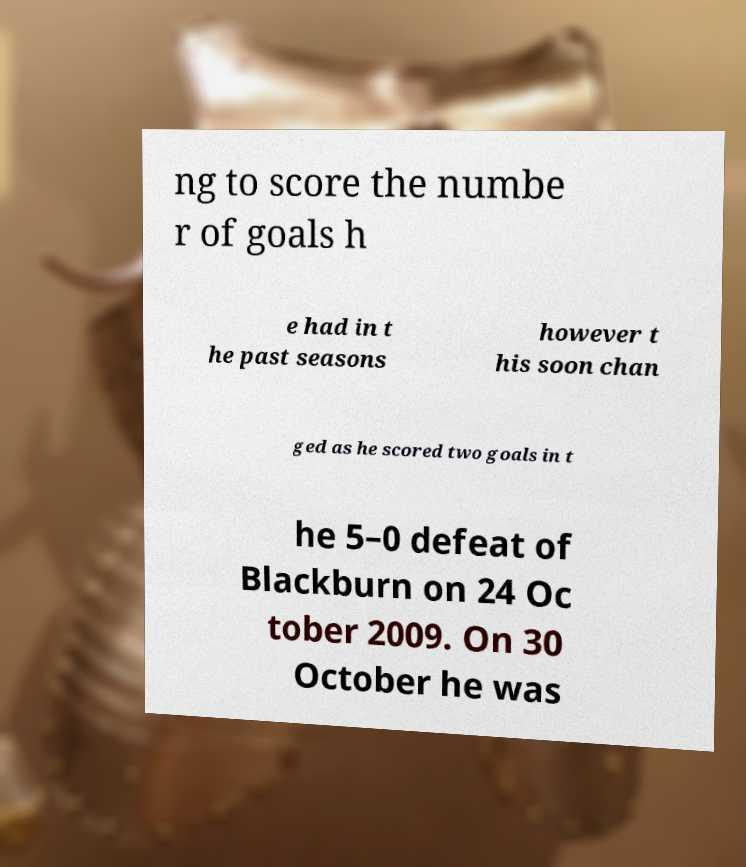Could you extract and type out the text from this image? ng to score the numbe r of goals h e had in t he past seasons however t his soon chan ged as he scored two goals in t he 5–0 defeat of Blackburn on 24 Oc tober 2009. On 30 October he was 